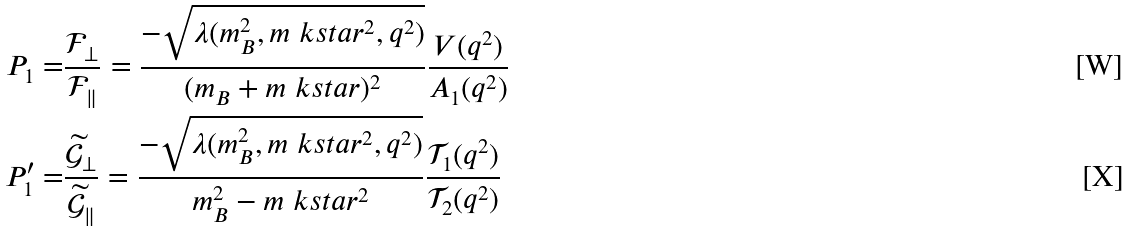Convert formula to latex. <formula><loc_0><loc_0><loc_500><loc_500>P _ { 1 } = & \frac { \mathcal { F } _ { \perp } } { \mathcal { F } _ { \| } } = \frac { - \sqrt { { \lambda } ( m _ { B } ^ { 2 } , m _ { \ } k s t a r ^ { 2 } , q ^ { 2 } ) } } { ( m _ { B } + m _ { \ } k s t a r ) ^ { 2 } } \frac { V ( q ^ { 2 } ) } { A _ { 1 } ( q ^ { 2 } ) } \\ P ^ { \prime } _ { 1 } = & \frac { \widetilde { \mathcal { G } } _ { \perp } } { \widetilde { \mathcal { G } } _ { \| } } = \frac { - \sqrt { { \lambda } ( m _ { B } ^ { 2 } , m _ { \ } k s t a r ^ { 2 } , q ^ { 2 } ) } } { m _ { B } ^ { 2 } - m _ { \ } k s t a r ^ { 2 } } \frac { \mathcal { T } _ { 1 } ( q ^ { 2 } ) } { \mathcal { T } _ { 2 } ( q ^ { 2 } ) }</formula> 